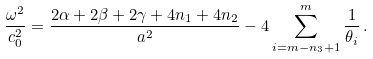Convert formula to latex. <formula><loc_0><loc_0><loc_500><loc_500>\frac { \omega ^ { 2 } } { c _ { 0 } ^ { 2 } } = \frac { 2 \alpha + 2 \beta + 2 \gamma + 4 n _ { 1 } + 4 n _ { 2 } } { a ^ { 2 } } - 4 \sum _ { i = m - n _ { 3 } + 1 } ^ { m } \frac { 1 } { \theta _ { i } } \, .</formula> 